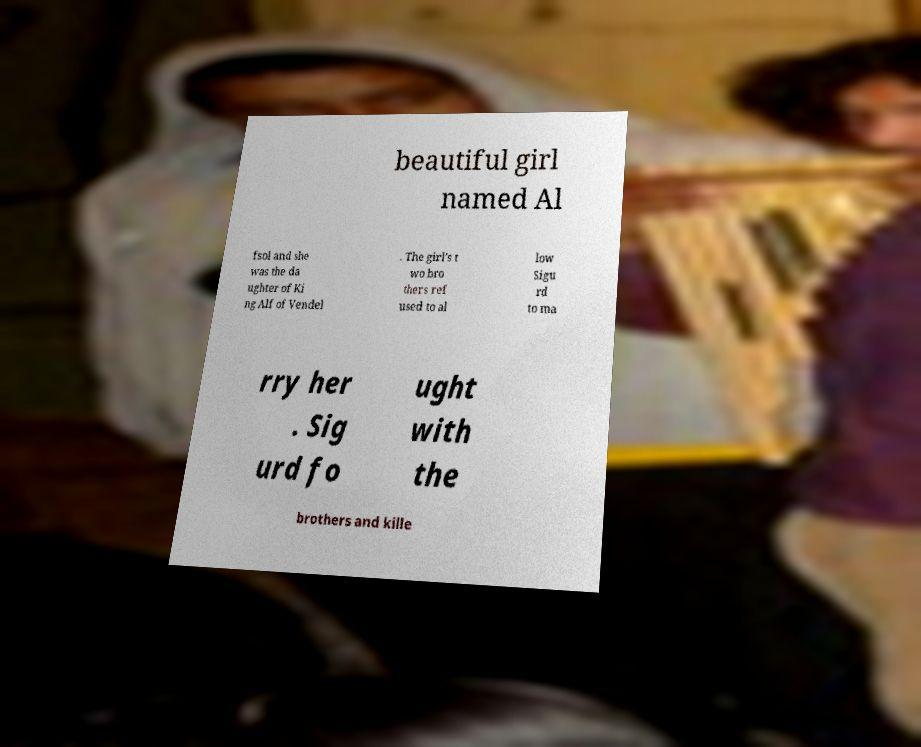Please read and relay the text visible in this image. What does it say? beautiful girl named Al fsol and she was the da ughter of Ki ng Alf of Vendel . The girl's t wo bro thers ref used to al low Sigu rd to ma rry her . Sig urd fo ught with the brothers and kille 